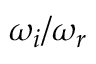<formula> <loc_0><loc_0><loc_500><loc_500>\omega _ { i } / \omega _ { r }</formula> 